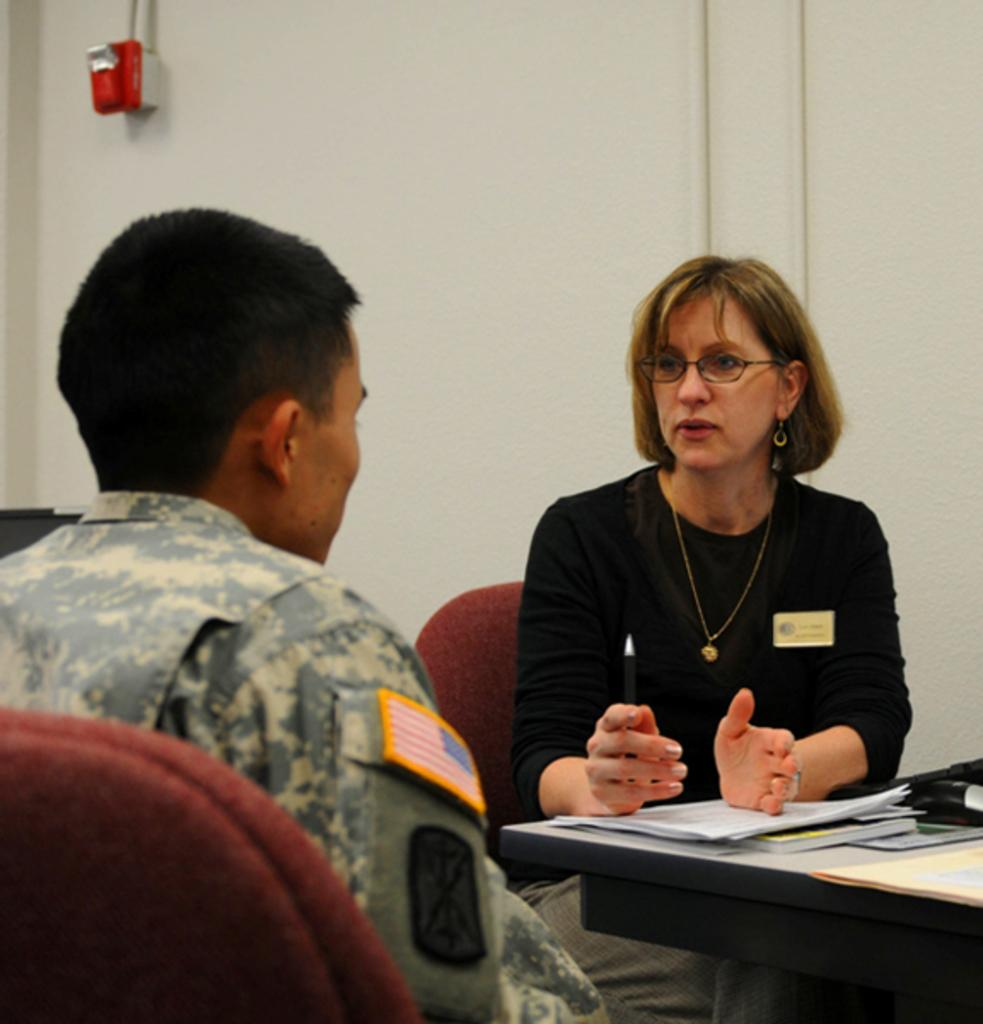How many people are present in the image? There are two people, a man and a woman, present in the image. What is the woman doing in the image? The woman is speaking. What is on the table in front of them? The table has papers and books on it. What can be seen in the background of the image? There is a wall in the background of the image. What type of cherries are being served for lunch in the image? There is no mention of cherries or lunch in the image; it features a man and a woman with a table containing papers and books. 